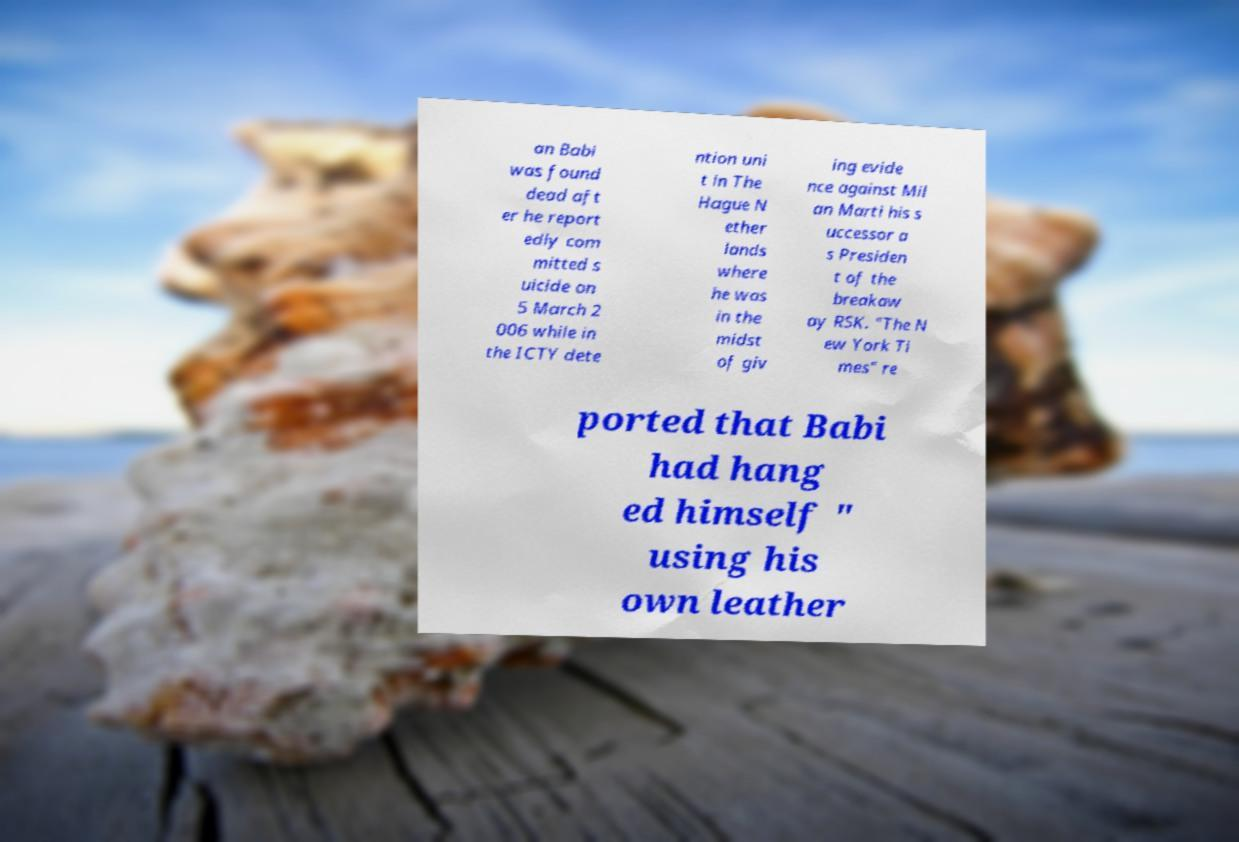What messages or text are displayed in this image? I need them in a readable, typed format. an Babi was found dead aft er he report edly com mitted s uicide on 5 March 2 006 while in the ICTY dete ntion uni t in The Hague N ether lands where he was in the midst of giv ing evide nce against Mil an Marti his s uccessor a s Presiden t of the breakaw ay RSK. "The N ew York Ti mes" re ported that Babi had hang ed himself " using his own leather 